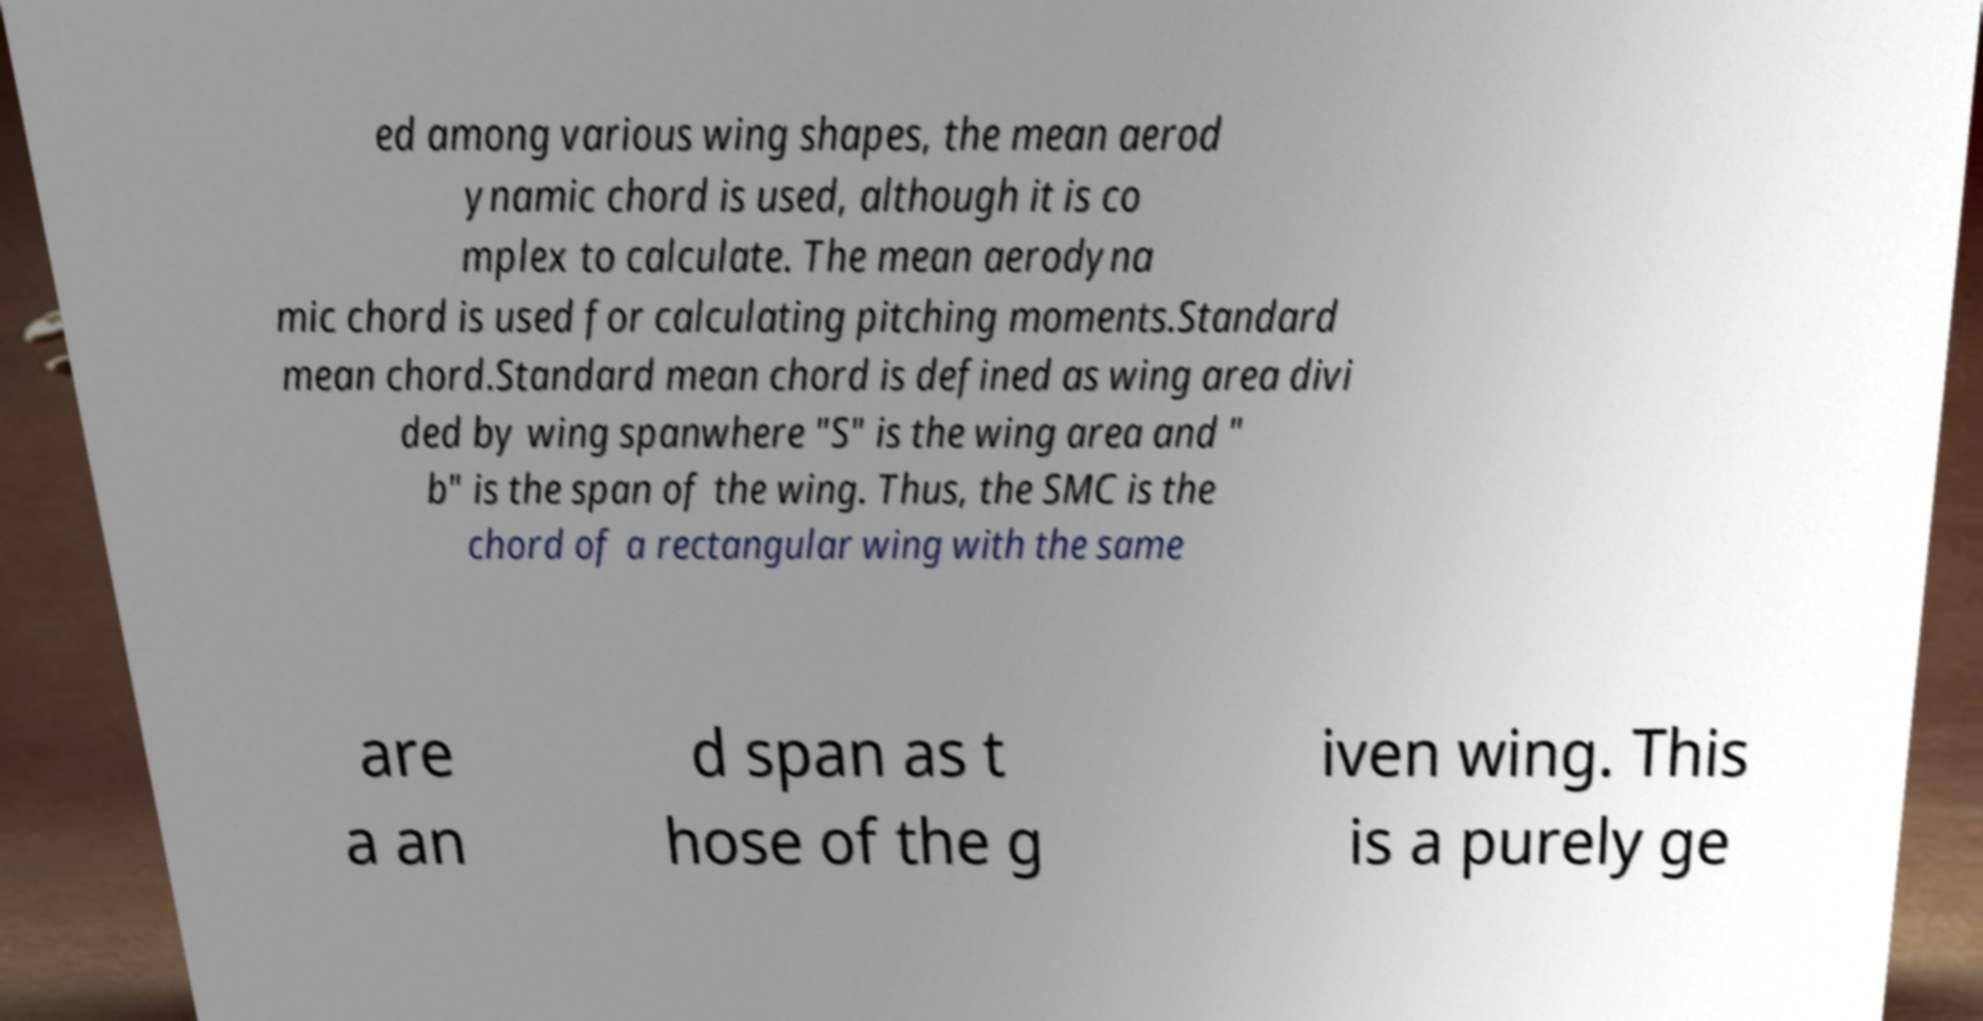Can you read and provide the text displayed in the image?This photo seems to have some interesting text. Can you extract and type it out for me? ed among various wing shapes, the mean aerod ynamic chord is used, although it is co mplex to calculate. The mean aerodyna mic chord is used for calculating pitching moments.Standard mean chord.Standard mean chord is defined as wing area divi ded by wing spanwhere "S" is the wing area and " b" is the span of the wing. Thus, the SMC is the chord of a rectangular wing with the same are a an d span as t hose of the g iven wing. This is a purely ge 